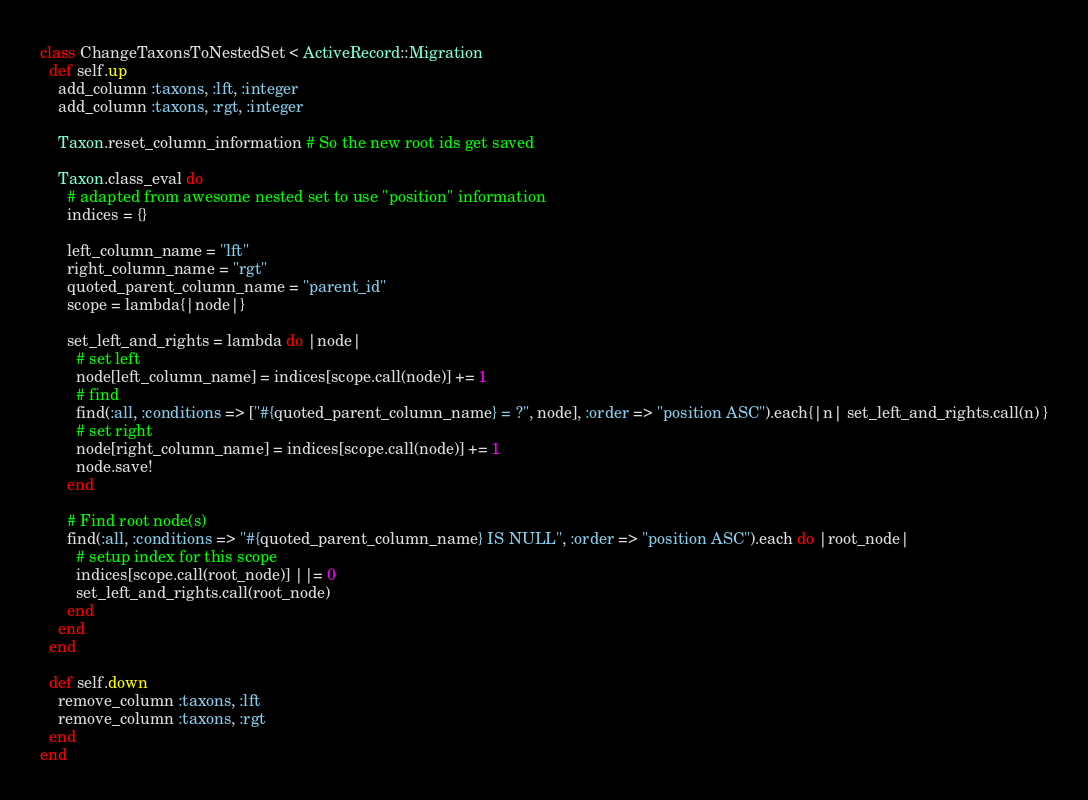<code> <loc_0><loc_0><loc_500><loc_500><_Ruby_>class ChangeTaxonsToNestedSet < ActiveRecord::Migration
  def self.up
    add_column :taxons, :lft, :integer
    add_column :taxons, :rgt, :integer

    Taxon.reset_column_information # So the new root ids get saved

    Taxon.class_eval do
      # adapted from awesome nested set to use "position" information
      indices = {}

      left_column_name = "lft"
      right_column_name = "rgt"
      quoted_parent_column_name = "parent_id"
      scope = lambda{|node|}

      set_left_and_rights = lambda do |node|
        # set left
        node[left_column_name] = indices[scope.call(node)] += 1
        # find
        find(:all, :conditions => ["#{quoted_parent_column_name} = ?", node], :order => "position ASC").each{|n| set_left_and_rights.call(n) }
        # set right
        node[right_column_name] = indices[scope.call(node)] += 1
        node.save!
      end

      # Find root node(s)
      find(:all, :conditions => "#{quoted_parent_column_name} IS NULL", :order => "position ASC").each do |root_node|
        # setup index for this scope
        indices[scope.call(root_node)] ||= 0
        set_left_and_rights.call(root_node)
      end
    end
  end

  def self.down
    remove_column :taxons, :lft
    remove_column :taxons, :rgt
  end
end
</code> 